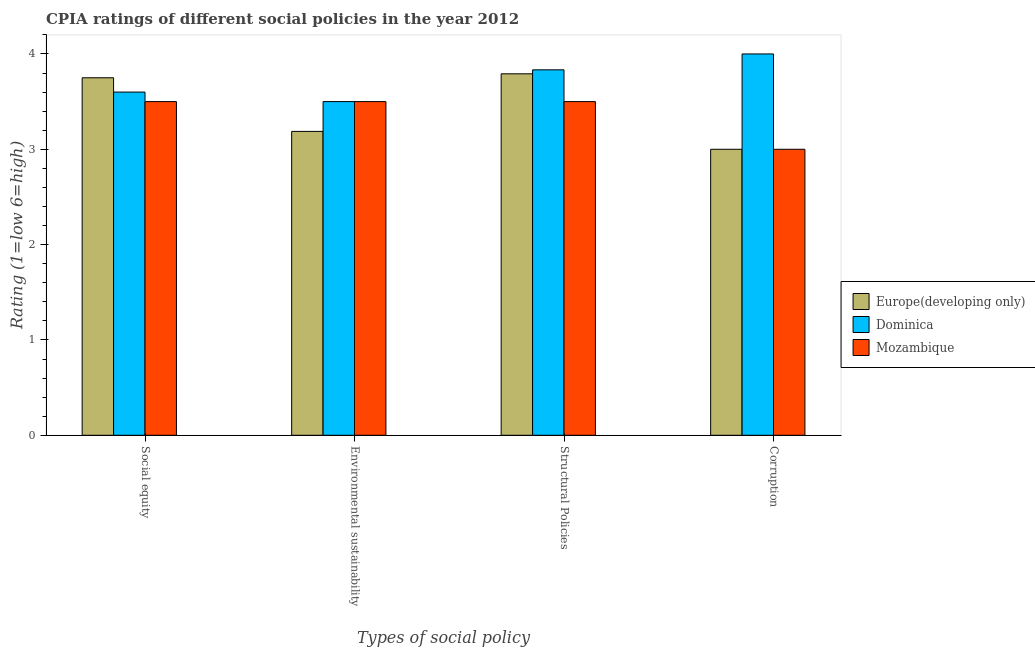Are the number of bars per tick equal to the number of legend labels?
Ensure brevity in your answer.  Yes. What is the label of the 3rd group of bars from the left?
Your answer should be compact. Structural Policies. What is the cpia rating of social equity in Europe(developing only)?
Provide a short and direct response. 3.75. Across all countries, what is the maximum cpia rating of structural policies?
Your answer should be very brief. 3.83. Across all countries, what is the minimum cpia rating of corruption?
Give a very brief answer. 3. In which country was the cpia rating of social equity maximum?
Give a very brief answer. Europe(developing only). In which country was the cpia rating of environmental sustainability minimum?
Offer a terse response. Europe(developing only). What is the total cpia rating of social equity in the graph?
Your response must be concise. 10.85. What is the difference between the cpia rating of social equity in Dominica and that in Europe(developing only)?
Your answer should be compact. -0.15. What is the difference between the cpia rating of corruption in Europe(developing only) and the cpia rating of environmental sustainability in Dominica?
Give a very brief answer. -0.5. What is the average cpia rating of environmental sustainability per country?
Your response must be concise. 3.4. What is the difference between the cpia rating of social equity and cpia rating of environmental sustainability in Dominica?
Offer a terse response. 0.1. In how many countries, is the cpia rating of social equity greater than 0.8 ?
Your answer should be very brief. 3. What is the ratio of the cpia rating of structural policies in Dominica to that in Europe(developing only)?
Your answer should be compact. 1.01. Is the difference between the cpia rating of environmental sustainability in Dominica and Europe(developing only) greater than the difference between the cpia rating of corruption in Dominica and Europe(developing only)?
Provide a succinct answer. No. What is the difference between the highest and the second highest cpia rating of corruption?
Your response must be concise. 1. What is the difference between the highest and the lowest cpia rating of corruption?
Ensure brevity in your answer.  1. In how many countries, is the cpia rating of structural policies greater than the average cpia rating of structural policies taken over all countries?
Make the answer very short. 2. Is it the case that in every country, the sum of the cpia rating of social equity and cpia rating of environmental sustainability is greater than the sum of cpia rating of structural policies and cpia rating of corruption?
Give a very brief answer. No. What does the 1st bar from the left in Structural Policies represents?
Offer a terse response. Europe(developing only). What does the 3rd bar from the right in Corruption represents?
Provide a succinct answer. Europe(developing only). Is it the case that in every country, the sum of the cpia rating of social equity and cpia rating of environmental sustainability is greater than the cpia rating of structural policies?
Your answer should be compact. Yes. How many bars are there?
Your answer should be very brief. 12. How many countries are there in the graph?
Provide a succinct answer. 3. What is the difference between two consecutive major ticks on the Y-axis?
Ensure brevity in your answer.  1. Does the graph contain grids?
Offer a terse response. No. How many legend labels are there?
Provide a short and direct response. 3. What is the title of the graph?
Keep it short and to the point. CPIA ratings of different social policies in the year 2012. Does "Sri Lanka" appear as one of the legend labels in the graph?
Give a very brief answer. No. What is the label or title of the X-axis?
Give a very brief answer. Types of social policy. What is the Rating (1=low 6=high) of Europe(developing only) in Social equity?
Provide a short and direct response. 3.75. What is the Rating (1=low 6=high) in Dominica in Social equity?
Offer a very short reply. 3.6. What is the Rating (1=low 6=high) in Mozambique in Social equity?
Your answer should be compact. 3.5. What is the Rating (1=low 6=high) in Europe(developing only) in Environmental sustainability?
Your response must be concise. 3.19. What is the Rating (1=low 6=high) in Dominica in Environmental sustainability?
Your answer should be very brief. 3.5. What is the Rating (1=low 6=high) in Europe(developing only) in Structural Policies?
Your answer should be very brief. 3.79. What is the Rating (1=low 6=high) of Dominica in Structural Policies?
Provide a short and direct response. 3.83. Across all Types of social policy, what is the maximum Rating (1=low 6=high) in Europe(developing only)?
Make the answer very short. 3.79. Across all Types of social policy, what is the maximum Rating (1=low 6=high) in Dominica?
Your response must be concise. 4. Across all Types of social policy, what is the maximum Rating (1=low 6=high) in Mozambique?
Make the answer very short. 3.5. Across all Types of social policy, what is the minimum Rating (1=low 6=high) in Dominica?
Your answer should be compact. 3.5. What is the total Rating (1=low 6=high) of Europe(developing only) in the graph?
Your answer should be very brief. 13.73. What is the total Rating (1=low 6=high) of Dominica in the graph?
Your answer should be compact. 14.93. What is the difference between the Rating (1=low 6=high) of Europe(developing only) in Social equity and that in Environmental sustainability?
Keep it short and to the point. 0.56. What is the difference between the Rating (1=low 6=high) of Europe(developing only) in Social equity and that in Structural Policies?
Offer a terse response. -0.04. What is the difference between the Rating (1=low 6=high) of Dominica in Social equity and that in Structural Policies?
Your response must be concise. -0.23. What is the difference between the Rating (1=low 6=high) of Mozambique in Social equity and that in Structural Policies?
Your answer should be very brief. 0. What is the difference between the Rating (1=low 6=high) of Europe(developing only) in Social equity and that in Corruption?
Your response must be concise. 0.75. What is the difference between the Rating (1=low 6=high) of Dominica in Social equity and that in Corruption?
Provide a succinct answer. -0.4. What is the difference between the Rating (1=low 6=high) in Mozambique in Social equity and that in Corruption?
Offer a terse response. 0.5. What is the difference between the Rating (1=low 6=high) in Europe(developing only) in Environmental sustainability and that in Structural Policies?
Give a very brief answer. -0.6. What is the difference between the Rating (1=low 6=high) in Mozambique in Environmental sustainability and that in Structural Policies?
Offer a terse response. 0. What is the difference between the Rating (1=low 6=high) of Europe(developing only) in Environmental sustainability and that in Corruption?
Your answer should be very brief. 0.19. What is the difference between the Rating (1=low 6=high) of Mozambique in Environmental sustainability and that in Corruption?
Make the answer very short. 0.5. What is the difference between the Rating (1=low 6=high) in Europe(developing only) in Structural Policies and that in Corruption?
Offer a very short reply. 0.79. What is the difference between the Rating (1=low 6=high) in Dominica in Structural Policies and that in Corruption?
Your response must be concise. -0.17. What is the difference between the Rating (1=low 6=high) in Europe(developing only) in Social equity and the Rating (1=low 6=high) in Dominica in Environmental sustainability?
Your answer should be very brief. 0.25. What is the difference between the Rating (1=low 6=high) in Europe(developing only) in Social equity and the Rating (1=low 6=high) in Mozambique in Environmental sustainability?
Provide a succinct answer. 0.25. What is the difference between the Rating (1=low 6=high) of Europe(developing only) in Social equity and the Rating (1=low 6=high) of Dominica in Structural Policies?
Provide a succinct answer. -0.08. What is the difference between the Rating (1=low 6=high) of Dominica in Social equity and the Rating (1=low 6=high) of Mozambique in Corruption?
Make the answer very short. 0.6. What is the difference between the Rating (1=low 6=high) of Europe(developing only) in Environmental sustainability and the Rating (1=low 6=high) of Dominica in Structural Policies?
Your answer should be compact. -0.65. What is the difference between the Rating (1=low 6=high) in Europe(developing only) in Environmental sustainability and the Rating (1=low 6=high) in Mozambique in Structural Policies?
Your answer should be compact. -0.31. What is the difference between the Rating (1=low 6=high) in Europe(developing only) in Environmental sustainability and the Rating (1=low 6=high) in Dominica in Corruption?
Your answer should be very brief. -0.81. What is the difference between the Rating (1=low 6=high) in Europe(developing only) in Environmental sustainability and the Rating (1=low 6=high) in Mozambique in Corruption?
Ensure brevity in your answer.  0.19. What is the difference between the Rating (1=low 6=high) in Europe(developing only) in Structural Policies and the Rating (1=low 6=high) in Dominica in Corruption?
Ensure brevity in your answer.  -0.21. What is the difference between the Rating (1=low 6=high) in Europe(developing only) in Structural Policies and the Rating (1=low 6=high) in Mozambique in Corruption?
Keep it short and to the point. 0.79. What is the average Rating (1=low 6=high) of Europe(developing only) per Types of social policy?
Provide a short and direct response. 3.43. What is the average Rating (1=low 6=high) in Dominica per Types of social policy?
Ensure brevity in your answer.  3.73. What is the average Rating (1=low 6=high) in Mozambique per Types of social policy?
Your response must be concise. 3.38. What is the difference between the Rating (1=low 6=high) of Europe(developing only) and Rating (1=low 6=high) of Dominica in Social equity?
Provide a short and direct response. 0.15. What is the difference between the Rating (1=low 6=high) of Europe(developing only) and Rating (1=low 6=high) of Mozambique in Social equity?
Offer a very short reply. 0.25. What is the difference between the Rating (1=low 6=high) in Dominica and Rating (1=low 6=high) in Mozambique in Social equity?
Make the answer very short. 0.1. What is the difference between the Rating (1=low 6=high) of Europe(developing only) and Rating (1=low 6=high) of Dominica in Environmental sustainability?
Your response must be concise. -0.31. What is the difference between the Rating (1=low 6=high) in Europe(developing only) and Rating (1=low 6=high) in Mozambique in Environmental sustainability?
Your answer should be very brief. -0.31. What is the difference between the Rating (1=low 6=high) in Dominica and Rating (1=low 6=high) in Mozambique in Environmental sustainability?
Give a very brief answer. 0. What is the difference between the Rating (1=low 6=high) of Europe(developing only) and Rating (1=low 6=high) of Dominica in Structural Policies?
Offer a terse response. -0.04. What is the difference between the Rating (1=low 6=high) in Europe(developing only) and Rating (1=low 6=high) in Mozambique in Structural Policies?
Give a very brief answer. 0.29. What is the difference between the Rating (1=low 6=high) in Dominica and Rating (1=low 6=high) in Mozambique in Structural Policies?
Your answer should be compact. 0.33. What is the difference between the Rating (1=low 6=high) in Europe(developing only) and Rating (1=low 6=high) in Dominica in Corruption?
Provide a short and direct response. -1. What is the ratio of the Rating (1=low 6=high) of Europe(developing only) in Social equity to that in Environmental sustainability?
Your answer should be very brief. 1.18. What is the ratio of the Rating (1=low 6=high) of Dominica in Social equity to that in Environmental sustainability?
Ensure brevity in your answer.  1.03. What is the ratio of the Rating (1=low 6=high) of Dominica in Social equity to that in Structural Policies?
Provide a succinct answer. 0.94. What is the ratio of the Rating (1=low 6=high) of Dominica in Social equity to that in Corruption?
Ensure brevity in your answer.  0.9. What is the ratio of the Rating (1=low 6=high) of Mozambique in Social equity to that in Corruption?
Make the answer very short. 1.17. What is the ratio of the Rating (1=low 6=high) in Europe(developing only) in Environmental sustainability to that in Structural Policies?
Keep it short and to the point. 0.84. What is the ratio of the Rating (1=low 6=high) of Europe(developing only) in Environmental sustainability to that in Corruption?
Ensure brevity in your answer.  1.06. What is the ratio of the Rating (1=low 6=high) in Mozambique in Environmental sustainability to that in Corruption?
Provide a short and direct response. 1.17. What is the ratio of the Rating (1=low 6=high) of Europe(developing only) in Structural Policies to that in Corruption?
Provide a succinct answer. 1.26. What is the ratio of the Rating (1=low 6=high) in Dominica in Structural Policies to that in Corruption?
Ensure brevity in your answer.  0.96. What is the difference between the highest and the second highest Rating (1=low 6=high) of Europe(developing only)?
Give a very brief answer. 0.04. What is the difference between the highest and the second highest Rating (1=low 6=high) in Dominica?
Offer a terse response. 0.17. What is the difference between the highest and the second highest Rating (1=low 6=high) in Mozambique?
Give a very brief answer. 0. What is the difference between the highest and the lowest Rating (1=low 6=high) in Europe(developing only)?
Provide a succinct answer. 0.79. What is the difference between the highest and the lowest Rating (1=low 6=high) of Mozambique?
Provide a short and direct response. 0.5. 